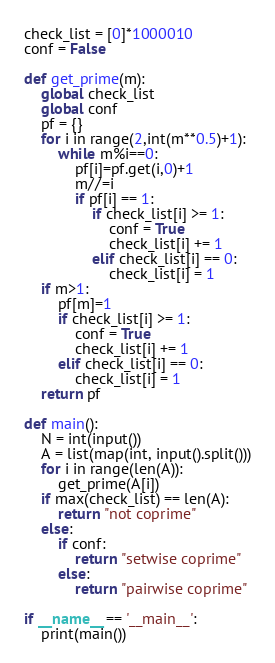<code> <loc_0><loc_0><loc_500><loc_500><_Python_>check_list = [0]*1000010
conf = False

def get_prime(m):
    global check_list
    global conf
    pf = {}
    for i in range(2,int(m**0.5)+1):
        while m%i==0:
            pf[i]=pf.get(i,0)+1
            m//=i
            if pf[i] == 1:
                if check_list[i] >= 1:
                    conf = True
                    check_list[i] += 1
                elif check_list[i] == 0:
                    check_list[i] = 1
    if m>1:
        pf[m]=1
        if check_list[i] >= 1:
            conf = True
            check_list[i] += 1
        elif check_list[i] == 0:
            check_list[i] = 1
    return pf

def main():
    N = int(input())
    A = list(map(int, input().split()))
    for i in range(len(A)):
        get_prime(A[i])
    if max(check_list) == len(A):
        return "not coprime"
    else:
        if conf:
            return "setwise coprime"
        else:
            return "pairwise coprime"

if __name__ == '__main__':
    print(main())
</code> 